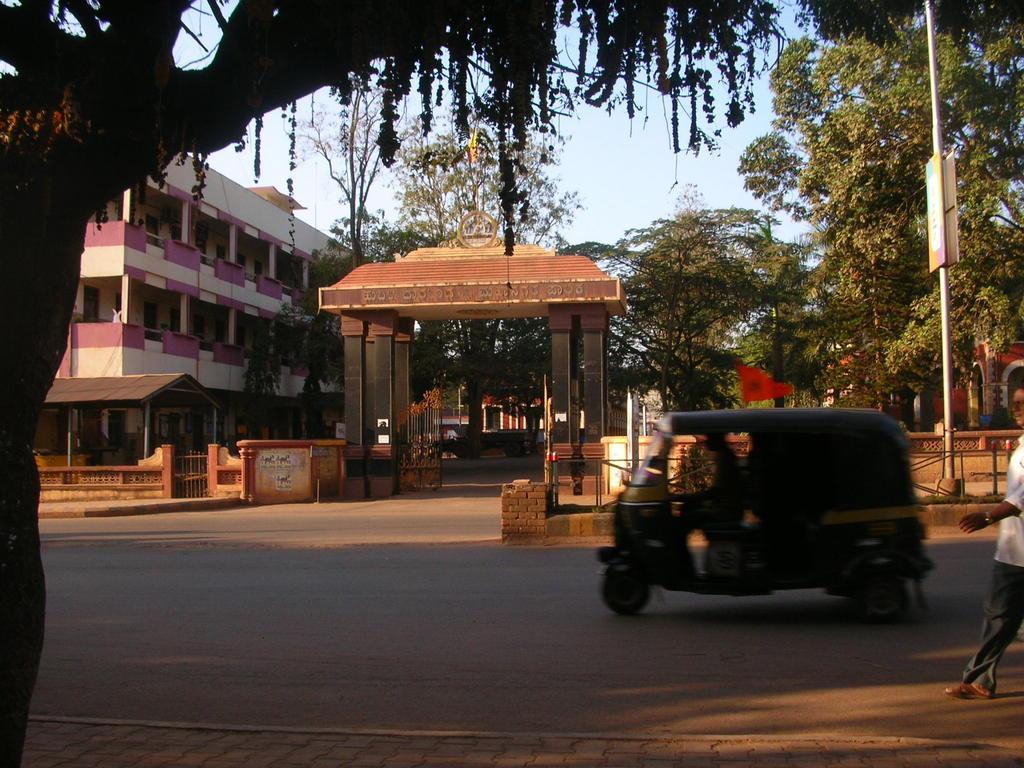Please provide a concise description of this image. At the bottom of the picture, we see the road. In the middle, we see a man is driving the auto. On the right side, we see a man in the white shirt is walking on the road. On the left side, we see a tree. Behind the auto, we see the footpath, wall and a pole. Behind that, we see the trees. In the middle, we see an arch and a gate. Beside that, we see a wall, gate and the roof of the shed in brown color. On the left side, we see a building in white and violet color. There are trees and a building in the background. At the top, we see the sky. 